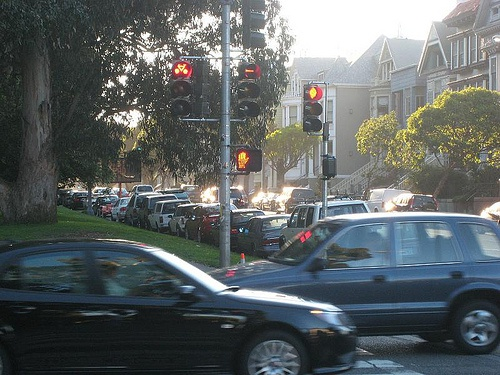Describe the objects in this image and their specific colors. I can see car in black, blue, darkblue, and gray tones, car in black, gray, and blue tones, car in black, gray, darkblue, and white tones, car in black, gray, lightgray, and darkgray tones, and car in black, gray, purple, and darkgray tones in this image. 